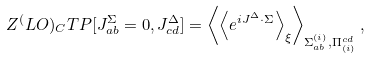Convert formula to latex. <formula><loc_0><loc_0><loc_500><loc_500>Z ^ { ( } L O ) _ { C } T P [ J _ { a b } ^ { \Sigma } = 0 , J _ { c d } ^ { \Delta } ] = \left \langle \left \langle e ^ { i J ^ { \Delta } \cdot \Sigma } \right \rangle _ { \xi } \right \rangle _ { \Sigma _ { a b } ^ { ( i ) } , \Pi ^ { c d } _ { ( i ) } } ,</formula> 